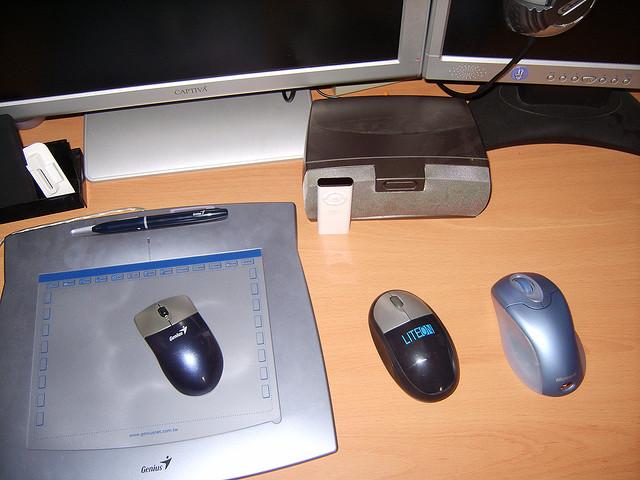What color is the mouse on the right?
Give a very brief answer. Blue. How many buttons are here?
Write a very short answer. 6. What common accessory is missing from this picture?
Keep it brief. Keyboard. 